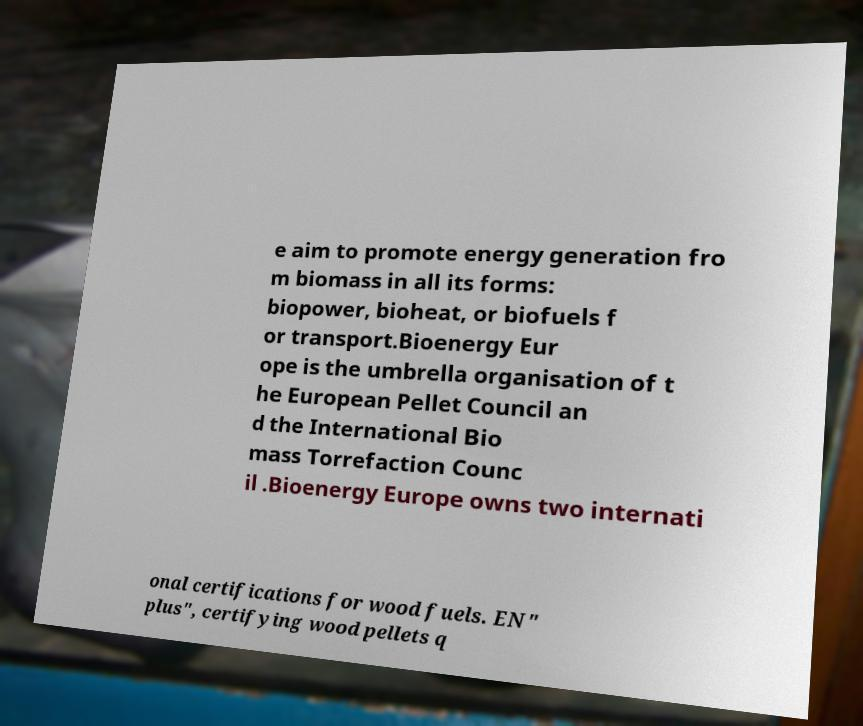Please read and relay the text visible in this image. What does it say? e aim to promote energy generation fro m biomass in all its forms: biopower, bioheat, or biofuels f or transport.Bioenergy Eur ope is the umbrella organisation of t he European Pellet Council an d the International Bio mass Torrefaction Counc il .Bioenergy Europe owns two internati onal certifications for wood fuels. EN" plus", certifying wood pellets q 